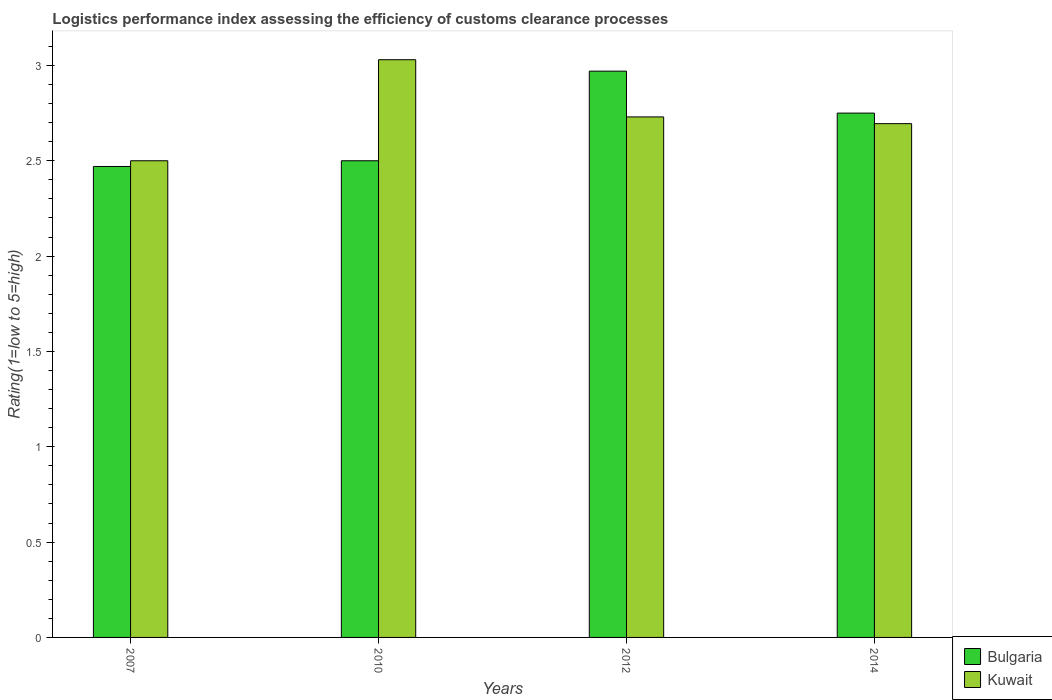Are the number of bars per tick equal to the number of legend labels?
Offer a terse response. Yes. What is the label of the 4th group of bars from the left?
Ensure brevity in your answer.  2014. In how many cases, is the number of bars for a given year not equal to the number of legend labels?
Your answer should be compact. 0. What is the Logistic performance index in Bulgaria in 2007?
Ensure brevity in your answer.  2.47. Across all years, what is the maximum Logistic performance index in Bulgaria?
Offer a very short reply. 2.97. Across all years, what is the minimum Logistic performance index in Bulgaria?
Make the answer very short. 2.47. What is the total Logistic performance index in Bulgaria in the graph?
Your answer should be very brief. 10.69. What is the difference between the Logistic performance index in Kuwait in 2010 and that in 2014?
Ensure brevity in your answer.  0.34. What is the difference between the Logistic performance index in Bulgaria in 2010 and the Logistic performance index in Kuwait in 2014?
Provide a short and direct response. -0.19. What is the average Logistic performance index in Kuwait per year?
Ensure brevity in your answer.  2.74. In the year 2007, what is the difference between the Logistic performance index in Kuwait and Logistic performance index in Bulgaria?
Your answer should be very brief. 0.03. In how many years, is the Logistic performance index in Bulgaria greater than 1.4?
Make the answer very short. 4. What is the ratio of the Logistic performance index in Kuwait in 2010 to that in 2014?
Ensure brevity in your answer.  1.12. Is the Logistic performance index in Bulgaria in 2010 less than that in 2012?
Offer a terse response. Yes. What is the difference between the highest and the second highest Logistic performance index in Bulgaria?
Keep it short and to the point. 0.22. What is the difference between the highest and the lowest Logistic performance index in Kuwait?
Ensure brevity in your answer.  0.53. What does the 1st bar from the left in 2007 represents?
Your answer should be compact. Bulgaria. What does the 1st bar from the right in 2012 represents?
Offer a terse response. Kuwait. How many bars are there?
Ensure brevity in your answer.  8. Are all the bars in the graph horizontal?
Make the answer very short. No. Are the values on the major ticks of Y-axis written in scientific E-notation?
Ensure brevity in your answer.  No. How many legend labels are there?
Your response must be concise. 2. What is the title of the graph?
Provide a succinct answer. Logistics performance index assessing the efficiency of customs clearance processes. Does "Fiji" appear as one of the legend labels in the graph?
Give a very brief answer. No. What is the label or title of the Y-axis?
Give a very brief answer. Rating(1=low to 5=high). What is the Rating(1=low to 5=high) of Bulgaria in 2007?
Give a very brief answer. 2.47. What is the Rating(1=low to 5=high) of Kuwait in 2010?
Keep it short and to the point. 3.03. What is the Rating(1=low to 5=high) of Bulgaria in 2012?
Offer a very short reply. 2.97. What is the Rating(1=low to 5=high) of Kuwait in 2012?
Your response must be concise. 2.73. What is the Rating(1=low to 5=high) of Bulgaria in 2014?
Keep it short and to the point. 2.75. What is the Rating(1=low to 5=high) of Kuwait in 2014?
Provide a succinct answer. 2.69. Across all years, what is the maximum Rating(1=low to 5=high) of Bulgaria?
Keep it short and to the point. 2.97. Across all years, what is the maximum Rating(1=low to 5=high) in Kuwait?
Your answer should be compact. 3.03. Across all years, what is the minimum Rating(1=low to 5=high) in Bulgaria?
Your answer should be very brief. 2.47. Across all years, what is the minimum Rating(1=low to 5=high) of Kuwait?
Your answer should be very brief. 2.5. What is the total Rating(1=low to 5=high) in Bulgaria in the graph?
Ensure brevity in your answer.  10.69. What is the total Rating(1=low to 5=high) in Kuwait in the graph?
Keep it short and to the point. 10.95. What is the difference between the Rating(1=low to 5=high) in Bulgaria in 2007 and that in 2010?
Offer a terse response. -0.03. What is the difference between the Rating(1=low to 5=high) in Kuwait in 2007 and that in 2010?
Keep it short and to the point. -0.53. What is the difference between the Rating(1=low to 5=high) of Kuwait in 2007 and that in 2012?
Keep it short and to the point. -0.23. What is the difference between the Rating(1=low to 5=high) of Bulgaria in 2007 and that in 2014?
Provide a short and direct response. -0.28. What is the difference between the Rating(1=low to 5=high) in Kuwait in 2007 and that in 2014?
Provide a short and direct response. -0.19. What is the difference between the Rating(1=low to 5=high) of Bulgaria in 2010 and that in 2012?
Your answer should be very brief. -0.47. What is the difference between the Rating(1=low to 5=high) in Kuwait in 2010 and that in 2012?
Provide a succinct answer. 0.3. What is the difference between the Rating(1=low to 5=high) in Bulgaria in 2010 and that in 2014?
Keep it short and to the point. -0.25. What is the difference between the Rating(1=low to 5=high) in Kuwait in 2010 and that in 2014?
Offer a terse response. 0.34. What is the difference between the Rating(1=low to 5=high) in Bulgaria in 2012 and that in 2014?
Offer a terse response. 0.22. What is the difference between the Rating(1=low to 5=high) of Kuwait in 2012 and that in 2014?
Make the answer very short. 0.04. What is the difference between the Rating(1=low to 5=high) in Bulgaria in 2007 and the Rating(1=low to 5=high) in Kuwait in 2010?
Ensure brevity in your answer.  -0.56. What is the difference between the Rating(1=low to 5=high) of Bulgaria in 2007 and the Rating(1=low to 5=high) of Kuwait in 2012?
Your answer should be compact. -0.26. What is the difference between the Rating(1=low to 5=high) of Bulgaria in 2007 and the Rating(1=low to 5=high) of Kuwait in 2014?
Keep it short and to the point. -0.22. What is the difference between the Rating(1=low to 5=high) of Bulgaria in 2010 and the Rating(1=low to 5=high) of Kuwait in 2012?
Make the answer very short. -0.23. What is the difference between the Rating(1=low to 5=high) in Bulgaria in 2010 and the Rating(1=low to 5=high) in Kuwait in 2014?
Provide a succinct answer. -0.19. What is the difference between the Rating(1=low to 5=high) in Bulgaria in 2012 and the Rating(1=low to 5=high) in Kuwait in 2014?
Your answer should be very brief. 0.28. What is the average Rating(1=low to 5=high) of Bulgaria per year?
Offer a terse response. 2.67. What is the average Rating(1=low to 5=high) of Kuwait per year?
Keep it short and to the point. 2.74. In the year 2007, what is the difference between the Rating(1=low to 5=high) in Bulgaria and Rating(1=low to 5=high) in Kuwait?
Give a very brief answer. -0.03. In the year 2010, what is the difference between the Rating(1=low to 5=high) of Bulgaria and Rating(1=low to 5=high) of Kuwait?
Ensure brevity in your answer.  -0.53. In the year 2012, what is the difference between the Rating(1=low to 5=high) of Bulgaria and Rating(1=low to 5=high) of Kuwait?
Keep it short and to the point. 0.24. In the year 2014, what is the difference between the Rating(1=low to 5=high) of Bulgaria and Rating(1=low to 5=high) of Kuwait?
Keep it short and to the point. 0.06. What is the ratio of the Rating(1=low to 5=high) in Kuwait in 2007 to that in 2010?
Keep it short and to the point. 0.83. What is the ratio of the Rating(1=low to 5=high) of Bulgaria in 2007 to that in 2012?
Your answer should be very brief. 0.83. What is the ratio of the Rating(1=low to 5=high) in Kuwait in 2007 to that in 2012?
Your answer should be compact. 0.92. What is the ratio of the Rating(1=low to 5=high) of Bulgaria in 2007 to that in 2014?
Your answer should be very brief. 0.9. What is the ratio of the Rating(1=low to 5=high) in Kuwait in 2007 to that in 2014?
Give a very brief answer. 0.93. What is the ratio of the Rating(1=low to 5=high) in Bulgaria in 2010 to that in 2012?
Your answer should be compact. 0.84. What is the ratio of the Rating(1=low to 5=high) in Kuwait in 2010 to that in 2012?
Keep it short and to the point. 1.11. What is the ratio of the Rating(1=low to 5=high) of Bulgaria in 2010 to that in 2014?
Offer a very short reply. 0.91. What is the ratio of the Rating(1=low to 5=high) of Kuwait in 2010 to that in 2014?
Ensure brevity in your answer.  1.12. What is the ratio of the Rating(1=low to 5=high) of Bulgaria in 2012 to that in 2014?
Offer a very short reply. 1.08. What is the ratio of the Rating(1=low to 5=high) in Kuwait in 2012 to that in 2014?
Offer a very short reply. 1.01. What is the difference between the highest and the second highest Rating(1=low to 5=high) of Bulgaria?
Give a very brief answer. 0.22. What is the difference between the highest and the lowest Rating(1=low to 5=high) of Kuwait?
Make the answer very short. 0.53. 